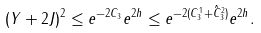Convert formula to latex. <formula><loc_0><loc_0><loc_500><loc_500>( Y + 2 J ) ^ { 2 } \leq e ^ { - 2 C _ { 3 } } e ^ { 2 h } \leq e ^ { - 2 ( C ^ { 1 } _ { 3 } + \hat { C } ^ { 2 } _ { 3 } ) } e ^ { 2 h } .</formula> 